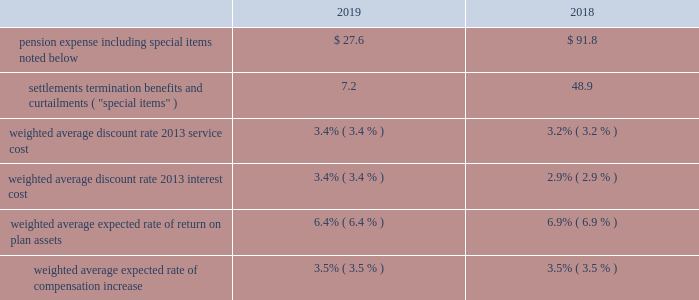Pension expense .
Pension expense decreased from the prior year due to lower pension settlements , lower loss amortization , primarily from favorable asset experience and the impact of higher discount rates , partially offset by lower expected returns on assets .
Special items ( settlements , termination benefits , and curtailments ) decreased from the prior year primarily due to lower pension settlement losses .
In fiscal year 2019 , special items of $ 7.2 included pension settlement losses of $ 6.4 , of which $ 5.0 was recorded during the second quarter and related to the u.s .
Supplementary pension plan , and $ .8 of termination benefits .
These amounts are reflected within "other non- operating income ( expense ) , net" on the consolidated income statements .
In fiscal year 2018 , special items of $ 48.9 included a pension settlement loss of $ 43.7 primarily in connection with the transfer of certain pension assets and payment obligations for our u.s .
Salaried and hourly plans to an insurer during the fourth quarter , $ 4.8 of pension settlement losses related to lump sum payouts from the u.s .
Supplementary pension plan , and $ .4 of termination benefits .
U.k .
Lloyds equalization ruling on 26 october 2018 , the united kingdom high court issued a ruling related to the equalization of pension plan participants 2019 benefits for the gender effects of guaranteed minimum pensions .
As a result of this ruling , we estimated the impact of retroactively increasing benefits in our u.k .
Plan in accordance with the high court ruling .
We treated the additional benefits as a prior service cost , which resulted in an increase to our projected benefit obligation and accumulated other comprehensive loss of $ 4.7 during the first quarter of fiscal year 2019 .
We are amortizing this cost over the average remaining life expectancy of the u.k .
Participants .
2020 outlook in fiscal year 2020 , we expect pension expense to be approximately $ 5 to $ 20 , which includes expected pension settlement losses of $ 5 to $ 10 , depending on the timing of retirements .
The expected range reflects lower expected interest cost and higher total assets , partially offset by higher expected loss amortization primarily due to the impact of lower discount rates .
In fiscal year 2020 , we expect pension expense to include approximately $ 105 for amortization of actuarial losses .
In fiscal year 2019 , pension expense included amortization of actuarial losses of $ 76.2 .
Net actuarial losses of $ 424.4 were recognized in accumulated other comprehensive income in fiscal year 2019 .
Actuarial ( gains ) losses are amortized into pension expense over prospective periods to the extent they are not offset by future gains or losses .
Future changes in the discount rate and actual returns on plan assets different from expected returns would impact the actuarial ( gains ) losses and resulting amortization in years beyond fiscal year 2020 .
Pension funding pension funding includes both contributions to funded plans and benefit payments for unfunded plans , which are primarily non-qualified plans .
With respect to funded plans , our funding policy is that contributions , combined with appreciation and earnings , will be sufficient to pay benefits without creating unnecessary surpluses .
In addition , we make contributions to satisfy all legal funding requirements while managing our capacity to benefit from tax deductions attributable to plan contributions .
With the assistance of third-party actuaries , we analyze the liabilities and demographics of each plan , which help guide the level of contributions .
During 2019 and 2018 , our cash contributions to funded plans and benefit payments for unfunded plans were $ 40.2 and $ 68.3 , respectively .
For fiscal year 2020 , cash contributions to defined benefit plans are estimated to be $ 30 to $ 40 .
The estimate is based on expected contributions to certain international plans and anticipated benefit payments for unfunded plans , which are dependent upon the timing of retirements .
Actual future contributions will depend on future funding legislation , discount rates , investment performance , plan design , and various other factors .
Refer to the contractual obligations discussion on page 37 for a projection of future contributions. .
Considering the years 2018-2019 , what is the decrease observed in the pension expenses? 
Rationale: it is the difference between those pension expenses values .
Computations: (91.8 - 27.6)
Answer: 64.2. 